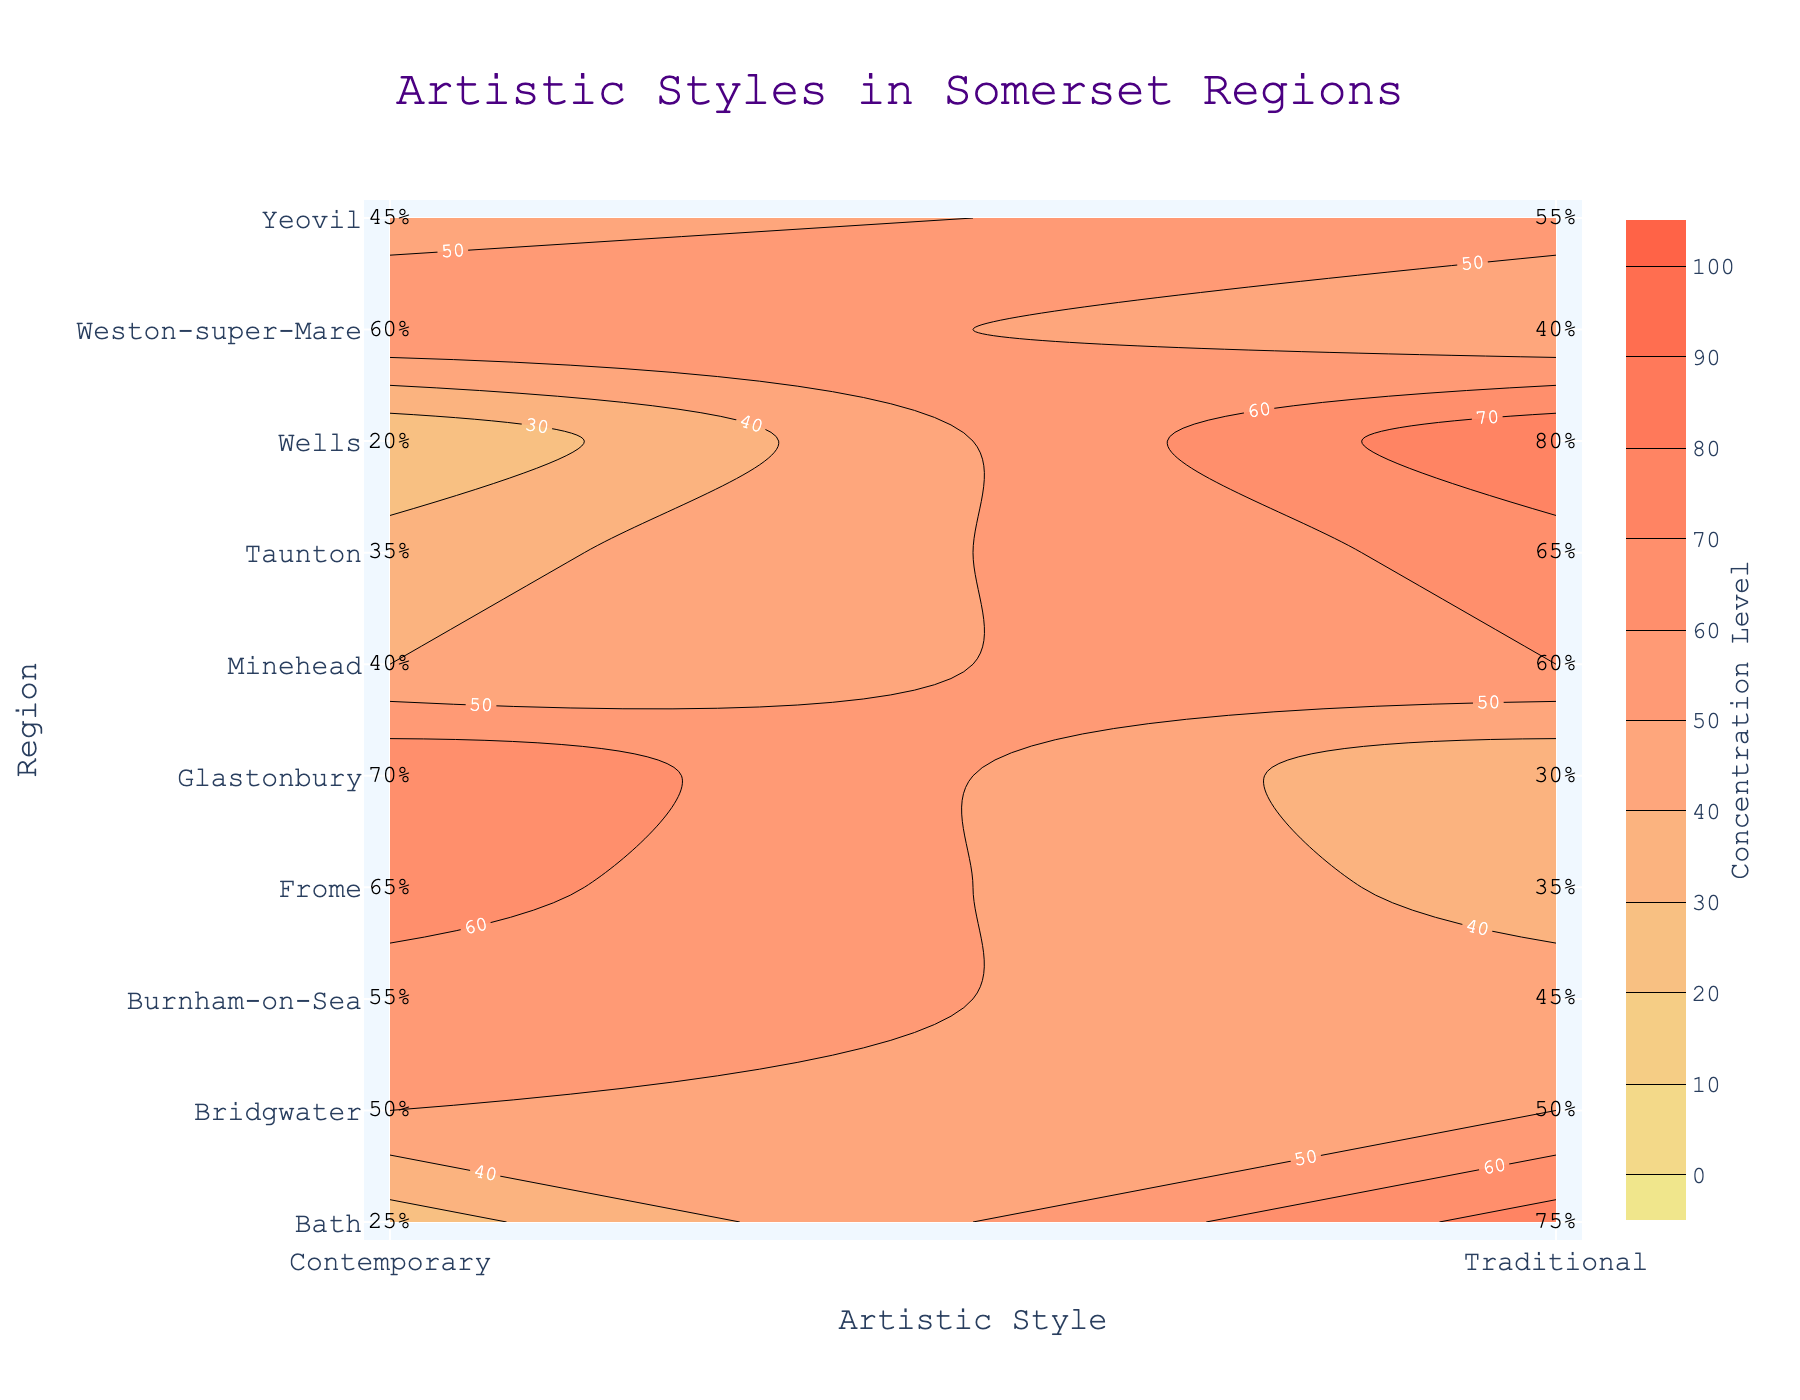What is the title of the plot? The title is often located at the top of the plot and describes what the plot is about. In this case, you can read the title directly.
Answer: Artistic Styles in Somerset Regions Which artistic style has the highest concentration in Wells? Locate Wells on the y-axis, then look at the contour levels for both Traditional and Contemporary styles. The higher concentration percentage indicates the dominant style.
Answer: Traditional What is the concentration level of Traditional artistic style in Yeovil? Find Yeovil on the y-axis, then identify the concentration level corresponding to the Traditional style on the x-axis. The label indicates the concentration level.
Answer: 55% Which region has the highest concentration of Contemporary artistic style? Identify the regions on the y-axis with the contour labels for the Contemporary style on the x-axis. Compare the percentages to determine the highest one.
Answer: Glastonbury How does the concentration of Traditional versus Contemporary styles compare in Frome? Find Frome on the y-axis and look at the percentages for both Traditional and Contemporary styles. Compare these values to see which one is higher.
Answer: Contemporary is higher Which regions have an equal concentration of Traditional and Contemporary artistic styles? Look across the regions on the y-axis to find ones where the percentages for both Traditional and Contemporary styles are equal on the x-axis.
Answer: Bridgwater What is the average concentration level of Traditional style across all regions? Add up all the concentration levels for the Traditional style across all regions and divide by the number of regions to calculate the average. Summing 75+40+65+55+30+80+50+35+60+45 = 535. There are 10 regions, so 535/10.
Answer: 53.5% How much higher is the concentration level of Traditional style in Bath compared to Glastonbury? Find the concentration levels of Traditional style in Bath and Glastonbury. Subtract the lower from the higher. For Bath, it's 75%, and for Glastonbury, it's 30%. Calculate 75 - 30.
Answer: 45% Which regions have a higher concentration of Traditional style compared to Contemporary style? For each region, compare the contour labels for Traditional and Contemporary styles. List regions where the percentage for Traditional is higher.
Answer: Bath, Taunton, Wells, Minehead What is the median concentration level of Contemporary style across all regions? List out the concentration levels for Contemporary style across all regions and find the middle value (sorted ascending order): 20, 25, 35, 40, 45, 50, 55, 60, 65, 70. The middle two values are 45 and 50. Calculate (45 + 50)/2.
Answer: 47.5% 